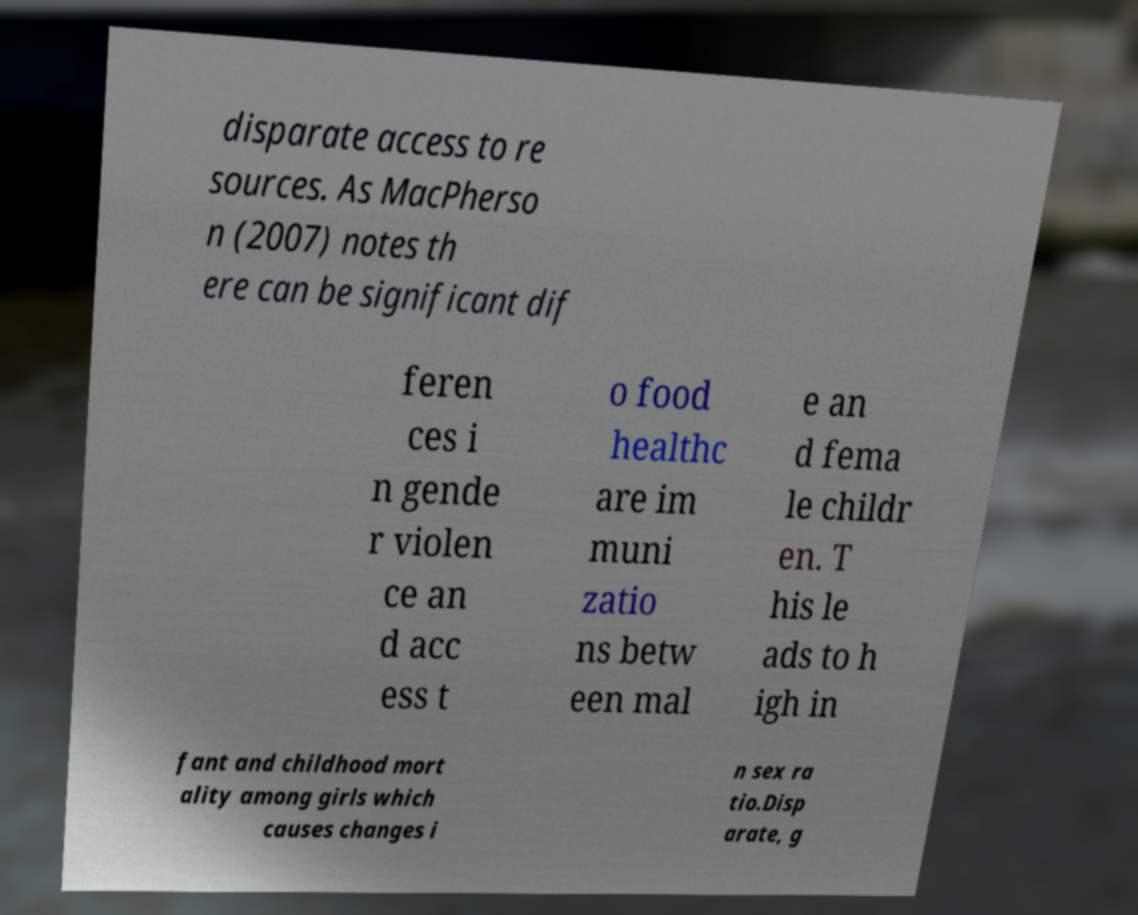I need the written content from this picture converted into text. Can you do that? disparate access to re sources. As MacPherso n (2007) notes th ere can be significant dif feren ces i n gende r violen ce an d acc ess t o food healthc are im muni zatio ns betw een mal e an d fema le childr en. T his le ads to h igh in fant and childhood mort ality among girls which causes changes i n sex ra tio.Disp arate, g 